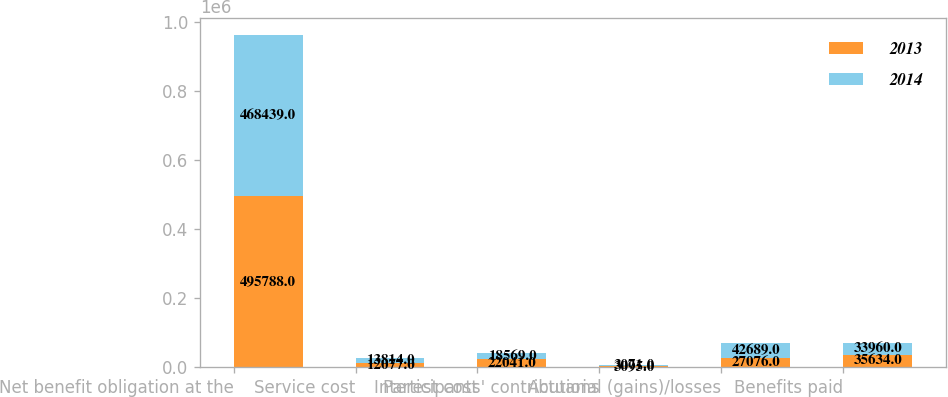Convert chart to OTSL. <chart><loc_0><loc_0><loc_500><loc_500><stacked_bar_chart><ecel><fcel>Net benefit obligation at the<fcel>Service cost<fcel>Interest cost<fcel>Participants' contributions<fcel>Actuarial (gains)/losses<fcel>Benefits paid<nl><fcel>2013<fcel>495788<fcel>12077<fcel>22041<fcel>3095<fcel>27076<fcel>35634<nl><fcel>2014<fcel>468439<fcel>13814<fcel>18569<fcel>3071<fcel>42689<fcel>33960<nl></chart> 